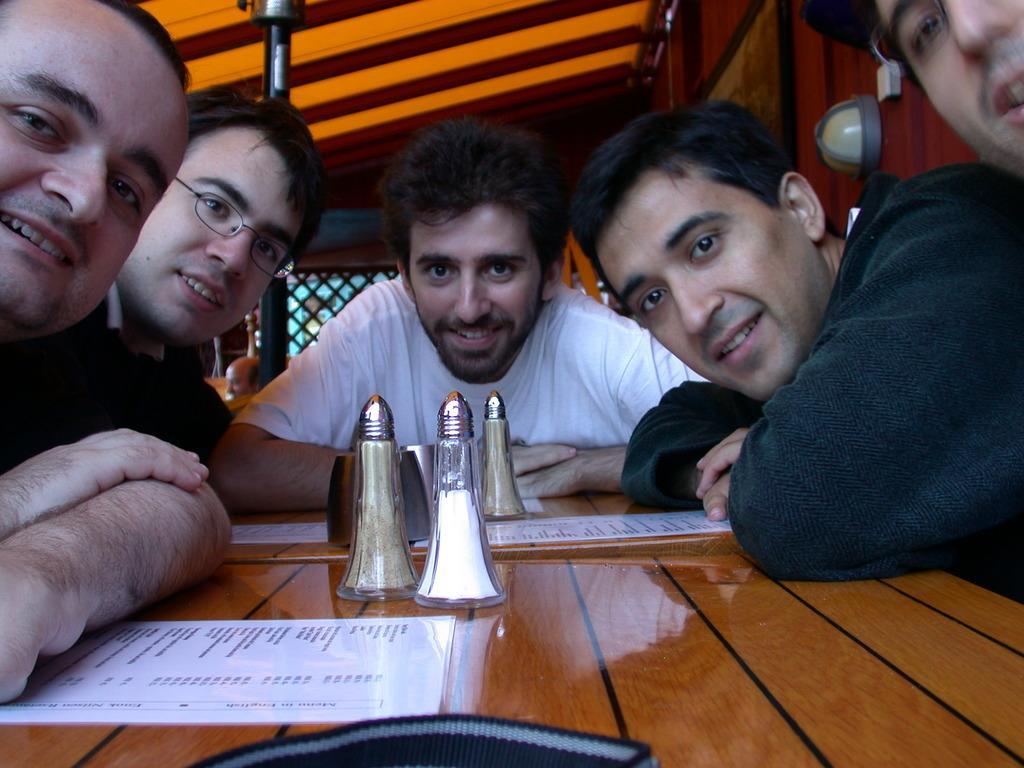How would you summarize this image in a sentence or two? In the center of the image there are people sitting around the table. On the table there are objects. There is a menu card. At the top of the image there is a shed. There is a pole in the background of the image. To the right side of the image there is a wall. 